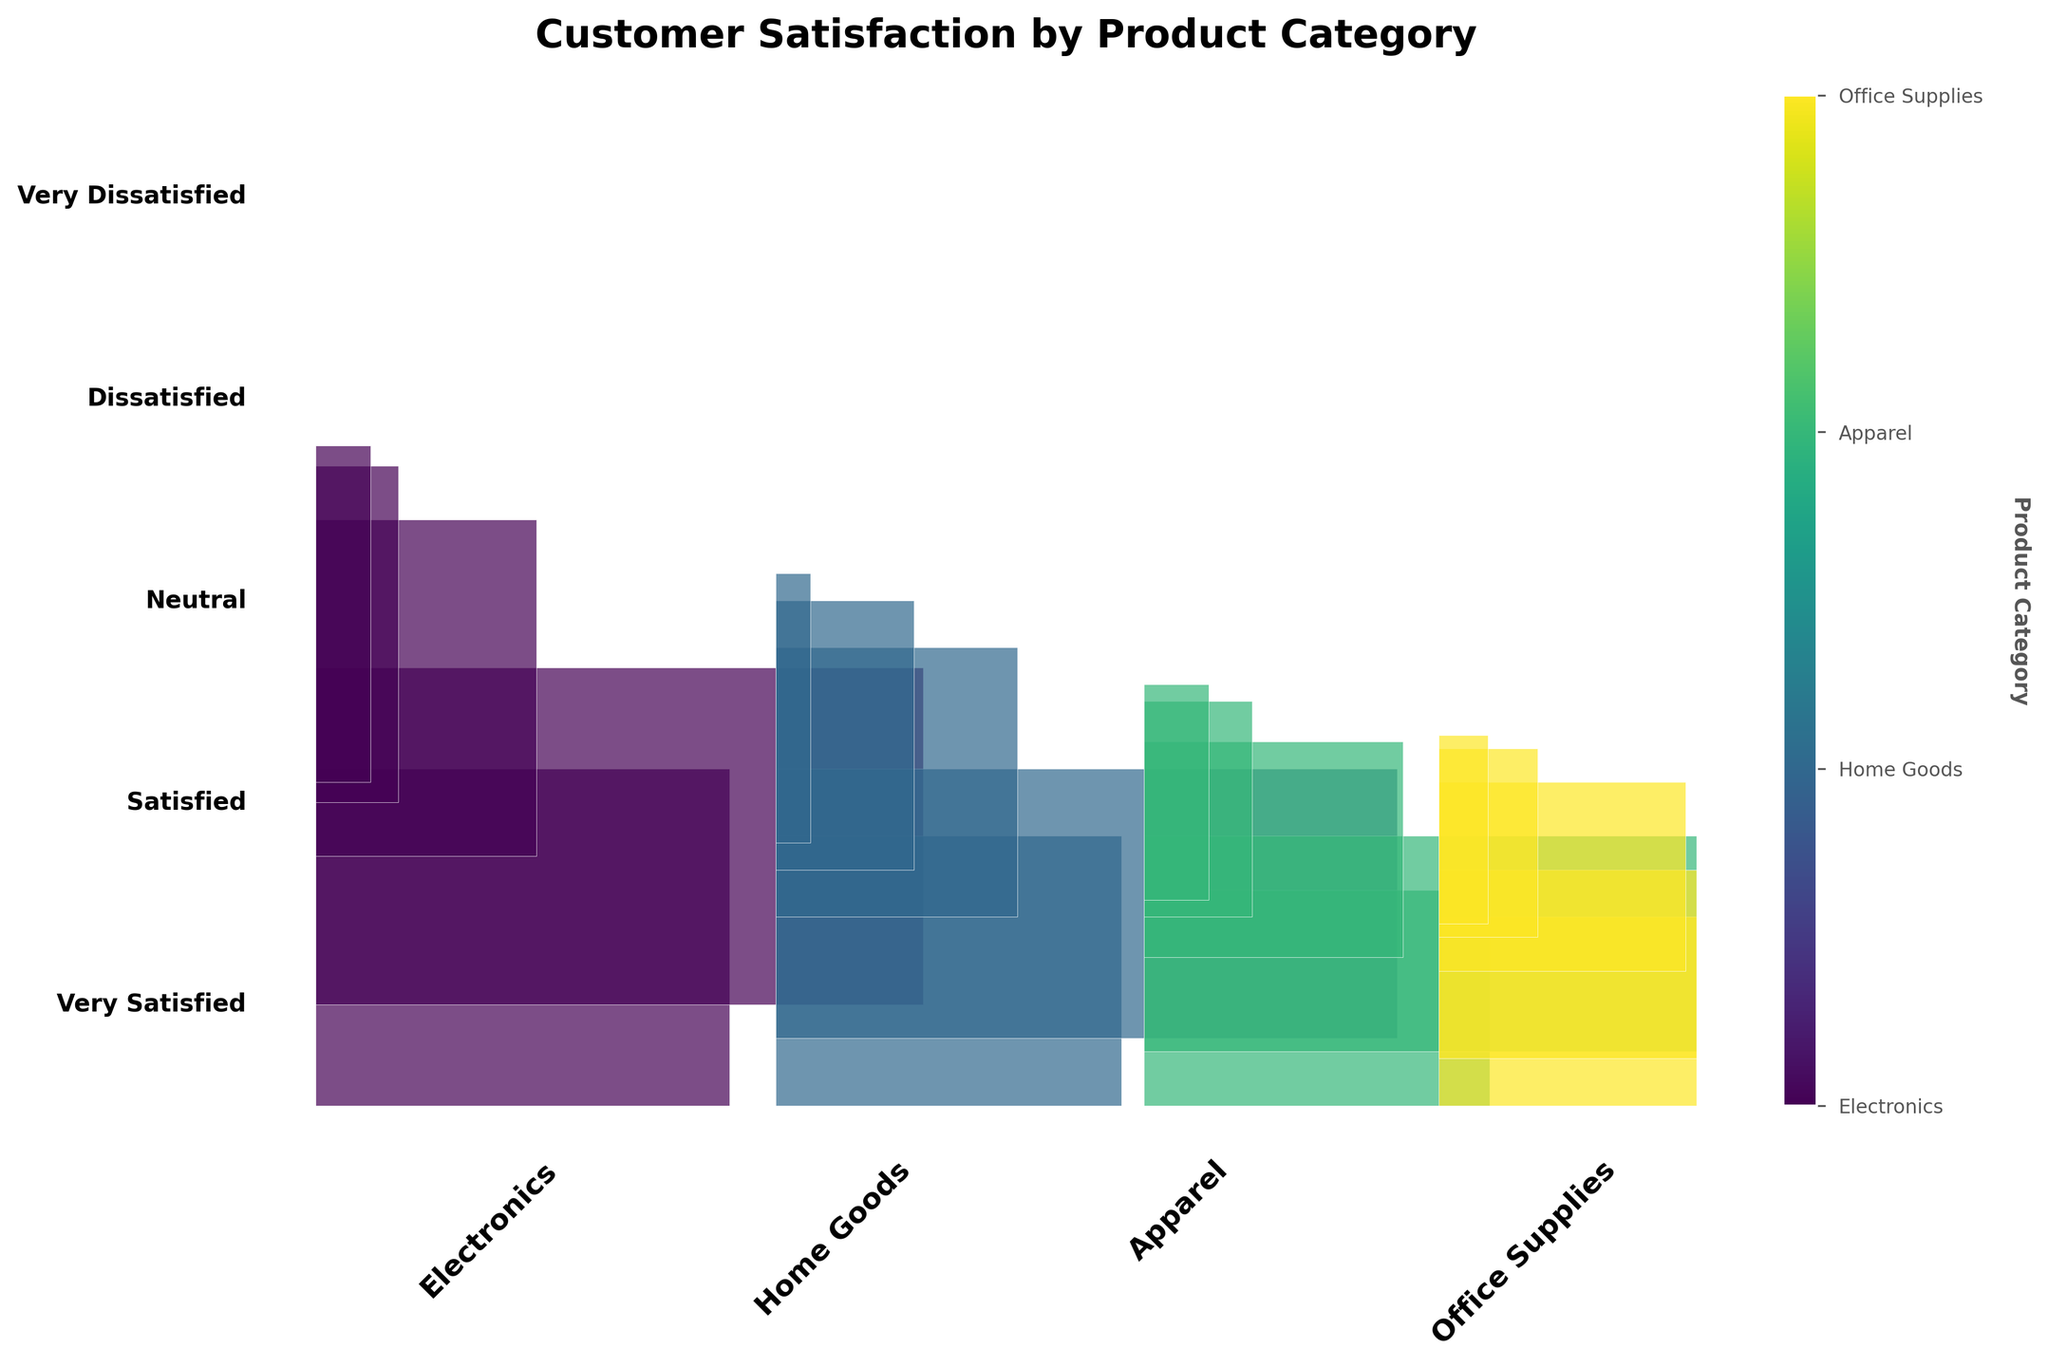How many product categories are shown in the plot? You can count the number of unique product categories listed along the x-axis at the bottom of the plot.
Answer: 4 Which product category has the highest proportion of 'Very Satisfied' customers? Look at each rectangle corresponding to 'Very Satisfied' in every product category and compare their heights. The tallest one indicates the highest proportion.
Answer: Electronics Which product category shows the least dissatisfaction overall? Examine the rectangles representing 'Dissatisfied' and 'Very Dissatisfied' customers across all product categories and find the smallest combined height.
Answer: Home Goods Between 'Home Goods' and 'Apparel', which category has a higher proportion of 'Neutral' customers? Compare the height of the rectangles for 'Neutral' customers between 'Home Goods' and 'Apparel'. The taller one has a higher proportion.
Answer: Home Goods What is the total proportion of 'Satisfied' and 'Very Satisfied' customers in the 'Office Supplies' category? Combine the heights of the 'Satisfied' and 'Very Satisfied' rectangles in the 'Office Supplies' category.
Answer: 80% For which satisfaction level is there the least variation across all product categories? Compare the width of each satisfaction level's rectangles across all product categories to find the one with least variation.
Answer: Neutral How does the 'Very Dissatisfied' level in 'Electronics' compare to 'Office Supplies'? Look at the width of the 'Very Dissatisfied' rectangles in both 'Electronics' and 'Office Supplies' and compare their heights in the respective categories.
Answer: Higher in Electronics Which satisfaction level predominantly occupies the 'Apparel' category? Check which satisfaction level rectangle has the greatest height in the 'Apparel' category.
Answer: Satisfied What is the combined height of 'Dissatisfied' and 'Very Dissatisfied' customers in 'Home Goods'? Add the heights of 'Dissatisfied' and 'Very Dissatisfied' rectangles in 'Home Goods'.
Answer: 25% Compare the proportion of 'Neutral' customers between 'Electronics' and 'Office Supplies'. Look at the 'Neutral' rectangles in both categories and compare their heights proportionally.
Answer: Higher in Electronics 